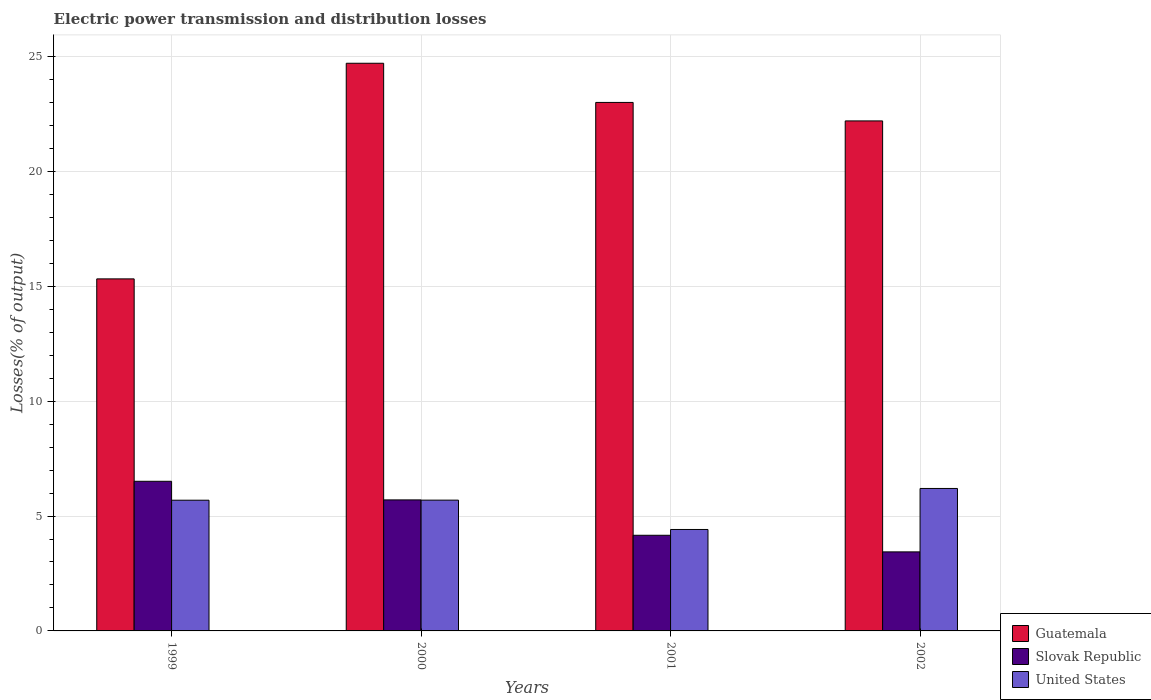How many groups of bars are there?
Your response must be concise. 4. Are the number of bars on each tick of the X-axis equal?
Ensure brevity in your answer.  Yes. How many bars are there on the 3rd tick from the left?
Give a very brief answer. 3. How many bars are there on the 3rd tick from the right?
Your response must be concise. 3. What is the electric power transmission and distribution losses in Slovak Republic in 2000?
Your answer should be compact. 5.7. Across all years, what is the maximum electric power transmission and distribution losses in Guatemala?
Your response must be concise. 24.7. Across all years, what is the minimum electric power transmission and distribution losses in Slovak Republic?
Offer a very short reply. 3.44. In which year was the electric power transmission and distribution losses in Slovak Republic maximum?
Keep it short and to the point. 1999. What is the total electric power transmission and distribution losses in Slovak Republic in the graph?
Make the answer very short. 19.82. What is the difference between the electric power transmission and distribution losses in Slovak Republic in 2000 and that in 2001?
Your response must be concise. 1.54. What is the difference between the electric power transmission and distribution losses in Guatemala in 2001 and the electric power transmission and distribution losses in Slovak Republic in 1999?
Keep it short and to the point. 16.49. What is the average electric power transmission and distribution losses in United States per year?
Make the answer very short. 5.5. In the year 2001, what is the difference between the electric power transmission and distribution losses in Guatemala and electric power transmission and distribution losses in United States?
Provide a succinct answer. 18.58. In how many years, is the electric power transmission and distribution losses in Guatemala greater than 6 %?
Provide a short and direct response. 4. What is the ratio of the electric power transmission and distribution losses in Guatemala in 2000 to that in 2002?
Ensure brevity in your answer.  1.11. Is the electric power transmission and distribution losses in United States in 1999 less than that in 2001?
Your answer should be compact. No. Is the difference between the electric power transmission and distribution losses in Guatemala in 1999 and 2002 greater than the difference between the electric power transmission and distribution losses in United States in 1999 and 2002?
Give a very brief answer. No. What is the difference between the highest and the second highest electric power transmission and distribution losses in United States?
Offer a terse response. 0.51. What is the difference between the highest and the lowest electric power transmission and distribution losses in United States?
Give a very brief answer. 1.79. In how many years, is the electric power transmission and distribution losses in United States greater than the average electric power transmission and distribution losses in United States taken over all years?
Keep it short and to the point. 3. What does the 3rd bar from the left in 2002 represents?
Provide a succinct answer. United States. What does the 3rd bar from the right in 1999 represents?
Give a very brief answer. Guatemala. Are all the bars in the graph horizontal?
Your answer should be compact. No. What is the difference between two consecutive major ticks on the Y-axis?
Your answer should be compact. 5. Where does the legend appear in the graph?
Ensure brevity in your answer.  Bottom right. How many legend labels are there?
Your answer should be compact. 3. What is the title of the graph?
Provide a short and direct response. Electric power transmission and distribution losses. What is the label or title of the X-axis?
Keep it short and to the point. Years. What is the label or title of the Y-axis?
Your response must be concise. Losses(% of output). What is the Losses(% of output) in Guatemala in 1999?
Provide a succinct answer. 15.32. What is the Losses(% of output) in Slovak Republic in 1999?
Provide a short and direct response. 6.51. What is the Losses(% of output) in United States in 1999?
Your response must be concise. 5.69. What is the Losses(% of output) in Guatemala in 2000?
Your response must be concise. 24.7. What is the Losses(% of output) of Slovak Republic in 2000?
Your response must be concise. 5.7. What is the Losses(% of output) in United States in 2000?
Provide a succinct answer. 5.69. What is the Losses(% of output) in Guatemala in 2001?
Make the answer very short. 23. What is the Losses(% of output) of Slovak Republic in 2001?
Offer a terse response. 4.16. What is the Losses(% of output) of United States in 2001?
Offer a very short reply. 4.41. What is the Losses(% of output) in Guatemala in 2002?
Ensure brevity in your answer.  22.19. What is the Losses(% of output) of Slovak Republic in 2002?
Provide a succinct answer. 3.44. What is the Losses(% of output) of United States in 2002?
Your response must be concise. 6.2. Across all years, what is the maximum Losses(% of output) in Guatemala?
Make the answer very short. 24.7. Across all years, what is the maximum Losses(% of output) of Slovak Republic?
Provide a short and direct response. 6.51. Across all years, what is the maximum Losses(% of output) in United States?
Your answer should be very brief. 6.2. Across all years, what is the minimum Losses(% of output) in Guatemala?
Give a very brief answer. 15.32. Across all years, what is the minimum Losses(% of output) in Slovak Republic?
Provide a succinct answer. 3.44. Across all years, what is the minimum Losses(% of output) in United States?
Offer a very short reply. 4.41. What is the total Losses(% of output) of Guatemala in the graph?
Offer a very short reply. 85.21. What is the total Losses(% of output) in Slovak Republic in the graph?
Your response must be concise. 19.82. What is the total Losses(% of output) in United States in the graph?
Offer a terse response. 21.99. What is the difference between the Losses(% of output) of Guatemala in 1999 and that in 2000?
Ensure brevity in your answer.  -9.38. What is the difference between the Losses(% of output) of Slovak Republic in 1999 and that in 2000?
Offer a very short reply. 0.81. What is the difference between the Losses(% of output) in United States in 1999 and that in 2000?
Provide a succinct answer. -0. What is the difference between the Losses(% of output) of Guatemala in 1999 and that in 2001?
Give a very brief answer. -7.68. What is the difference between the Losses(% of output) in Slovak Republic in 1999 and that in 2001?
Your answer should be very brief. 2.35. What is the difference between the Losses(% of output) in United States in 1999 and that in 2001?
Offer a very short reply. 1.27. What is the difference between the Losses(% of output) in Guatemala in 1999 and that in 2002?
Ensure brevity in your answer.  -6.87. What is the difference between the Losses(% of output) in Slovak Republic in 1999 and that in 2002?
Ensure brevity in your answer.  3.07. What is the difference between the Losses(% of output) of United States in 1999 and that in 2002?
Make the answer very short. -0.51. What is the difference between the Losses(% of output) in Guatemala in 2000 and that in 2001?
Make the answer very short. 1.7. What is the difference between the Losses(% of output) of Slovak Republic in 2000 and that in 2001?
Give a very brief answer. 1.54. What is the difference between the Losses(% of output) in United States in 2000 and that in 2001?
Offer a terse response. 1.28. What is the difference between the Losses(% of output) of Guatemala in 2000 and that in 2002?
Give a very brief answer. 2.51. What is the difference between the Losses(% of output) of Slovak Republic in 2000 and that in 2002?
Make the answer very short. 2.26. What is the difference between the Losses(% of output) of United States in 2000 and that in 2002?
Offer a very short reply. -0.51. What is the difference between the Losses(% of output) in Guatemala in 2001 and that in 2002?
Keep it short and to the point. 0.8. What is the difference between the Losses(% of output) of Slovak Republic in 2001 and that in 2002?
Give a very brief answer. 0.72. What is the difference between the Losses(% of output) of United States in 2001 and that in 2002?
Make the answer very short. -1.79. What is the difference between the Losses(% of output) in Guatemala in 1999 and the Losses(% of output) in Slovak Republic in 2000?
Make the answer very short. 9.62. What is the difference between the Losses(% of output) of Guatemala in 1999 and the Losses(% of output) of United States in 2000?
Offer a very short reply. 9.63. What is the difference between the Losses(% of output) in Slovak Republic in 1999 and the Losses(% of output) in United States in 2000?
Your answer should be compact. 0.82. What is the difference between the Losses(% of output) in Guatemala in 1999 and the Losses(% of output) in Slovak Republic in 2001?
Provide a succinct answer. 11.16. What is the difference between the Losses(% of output) in Guatemala in 1999 and the Losses(% of output) in United States in 2001?
Your answer should be compact. 10.91. What is the difference between the Losses(% of output) in Slovak Republic in 1999 and the Losses(% of output) in United States in 2001?
Your answer should be compact. 2.1. What is the difference between the Losses(% of output) in Guatemala in 1999 and the Losses(% of output) in Slovak Republic in 2002?
Your answer should be very brief. 11.88. What is the difference between the Losses(% of output) in Guatemala in 1999 and the Losses(% of output) in United States in 2002?
Provide a succinct answer. 9.12. What is the difference between the Losses(% of output) of Slovak Republic in 1999 and the Losses(% of output) of United States in 2002?
Provide a short and direct response. 0.31. What is the difference between the Losses(% of output) in Guatemala in 2000 and the Losses(% of output) in Slovak Republic in 2001?
Provide a succinct answer. 20.54. What is the difference between the Losses(% of output) in Guatemala in 2000 and the Losses(% of output) in United States in 2001?
Your answer should be compact. 20.29. What is the difference between the Losses(% of output) of Slovak Republic in 2000 and the Losses(% of output) of United States in 2001?
Offer a terse response. 1.29. What is the difference between the Losses(% of output) of Guatemala in 2000 and the Losses(% of output) of Slovak Republic in 2002?
Your answer should be compact. 21.26. What is the difference between the Losses(% of output) of Guatemala in 2000 and the Losses(% of output) of United States in 2002?
Provide a succinct answer. 18.5. What is the difference between the Losses(% of output) in Slovak Republic in 2000 and the Losses(% of output) in United States in 2002?
Offer a terse response. -0.5. What is the difference between the Losses(% of output) in Guatemala in 2001 and the Losses(% of output) in Slovak Republic in 2002?
Provide a succinct answer. 19.56. What is the difference between the Losses(% of output) of Guatemala in 2001 and the Losses(% of output) of United States in 2002?
Give a very brief answer. 16.8. What is the difference between the Losses(% of output) of Slovak Republic in 2001 and the Losses(% of output) of United States in 2002?
Provide a succinct answer. -2.04. What is the average Losses(% of output) in Guatemala per year?
Offer a terse response. 21.3. What is the average Losses(% of output) of Slovak Republic per year?
Ensure brevity in your answer.  4.95. What is the average Losses(% of output) of United States per year?
Offer a very short reply. 5.5. In the year 1999, what is the difference between the Losses(% of output) of Guatemala and Losses(% of output) of Slovak Republic?
Your answer should be very brief. 8.81. In the year 1999, what is the difference between the Losses(% of output) of Guatemala and Losses(% of output) of United States?
Your response must be concise. 9.63. In the year 1999, what is the difference between the Losses(% of output) of Slovak Republic and Losses(% of output) of United States?
Give a very brief answer. 0.82. In the year 2000, what is the difference between the Losses(% of output) in Guatemala and Losses(% of output) in Slovak Republic?
Your answer should be very brief. 19. In the year 2000, what is the difference between the Losses(% of output) in Guatemala and Losses(% of output) in United States?
Make the answer very short. 19.01. In the year 2000, what is the difference between the Losses(% of output) of Slovak Republic and Losses(% of output) of United States?
Provide a short and direct response. 0.01. In the year 2001, what is the difference between the Losses(% of output) in Guatemala and Losses(% of output) in Slovak Republic?
Provide a succinct answer. 18.84. In the year 2001, what is the difference between the Losses(% of output) of Guatemala and Losses(% of output) of United States?
Your answer should be very brief. 18.58. In the year 2001, what is the difference between the Losses(% of output) in Slovak Republic and Losses(% of output) in United States?
Your answer should be very brief. -0.25. In the year 2002, what is the difference between the Losses(% of output) of Guatemala and Losses(% of output) of Slovak Republic?
Your response must be concise. 18.75. In the year 2002, what is the difference between the Losses(% of output) of Guatemala and Losses(% of output) of United States?
Your answer should be very brief. 15.99. In the year 2002, what is the difference between the Losses(% of output) of Slovak Republic and Losses(% of output) of United States?
Offer a very short reply. -2.76. What is the ratio of the Losses(% of output) in Guatemala in 1999 to that in 2000?
Make the answer very short. 0.62. What is the ratio of the Losses(% of output) of Slovak Republic in 1999 to that in 2000?
Provide a short and direct response. 1.14. What is the ratio of the Losses(% of output) in United States in 1999 to that in 2000?
Give a very brief answer. 1. What is the ratio of the Losses(% of output) of Guatemala in 1999 to that in 2001?
Make the answer very short. 0.67. What is the ratio of the Losses(% of output) in Slovak Republic in 1999 to that in 2001?
Offer a very short reply. 1.56. What is the ratio of the Losses(% of output) in United States in 1999 to that in 2001?
Provide a succinct answer. 1.29. What is the ratio of the Losses(% of output) of Guatemala in 1999 to that in 2002?
Provide a short and direct response. 0.69. What is the ratio of the Losses(% of output) of Slovak Republic in 1999 to that in 2002?
Offer a very short reply. 1.89. What is the ratio of the Losses(% of output) of United States in 1999 to that in 2002?
Your answer should be very brief. 0.92. What is the ratio of the Losses(% of output) of Guatemala in 2000 to that in 2001?
Your response must be concise. 1.07. What is the ratio of the Losses(% of output) in Slovak Republic in 2000 to that in 2001?
Offer a very short reply. 1.37. What is the ratio of the Losses(% of output) in United States in 2000 to that in 2001?
Keep it short and to the point. 1.29. What is the ratio of the Losses(% of output) of Guatemala in 2000 to that in 2002?
Offer a very short reply. 1.11. What is the ratio of the Losses(% of output) in Slovak Republic in 2000 to that in 2002?
Make the answer very short. 1.66. What is the ratio of the Losses(% of output) in United States in 2000 to that in 2002?
Provide a succinct answer. 0.92. What is the ratio of the Losses(% of output) of Guatemala in 2001 to that in 2002?
Make the answer very short. 1.04. What is the ratio of the Losses(% of output) of Slovak Republic in 2001 to that in 2002?
Give a very brief answer. 1.21. What is the ratio of the Losses(% of output) in United States in 2001 to that in 2002?
Keep it short and to the point. 0.71. What is the difference between the highest and the second highest Losses(% of output) in Guatemala?
Provide a succinct answer. 1.7. What is the difference between the highest and the second highest Losses(% of output) in Slovak Republic?
Your answer should be compact. 0.81. What is the difference between the highest and the second highest Losses(% of output) of United States?
Offer a terse response. 0.51. What is the difference between the highest and the lowest Losses(% of output) in Guatemala?
Your response must be concise. 9.38. What is the difference between the highest and the lowest Losses(% of output) in Slovak Republic?
Your answer should be compact. 3.07. What is the difference between the highest and the lowest Losses(% of output) in United States?
Your answer should be compact. 1.79. 